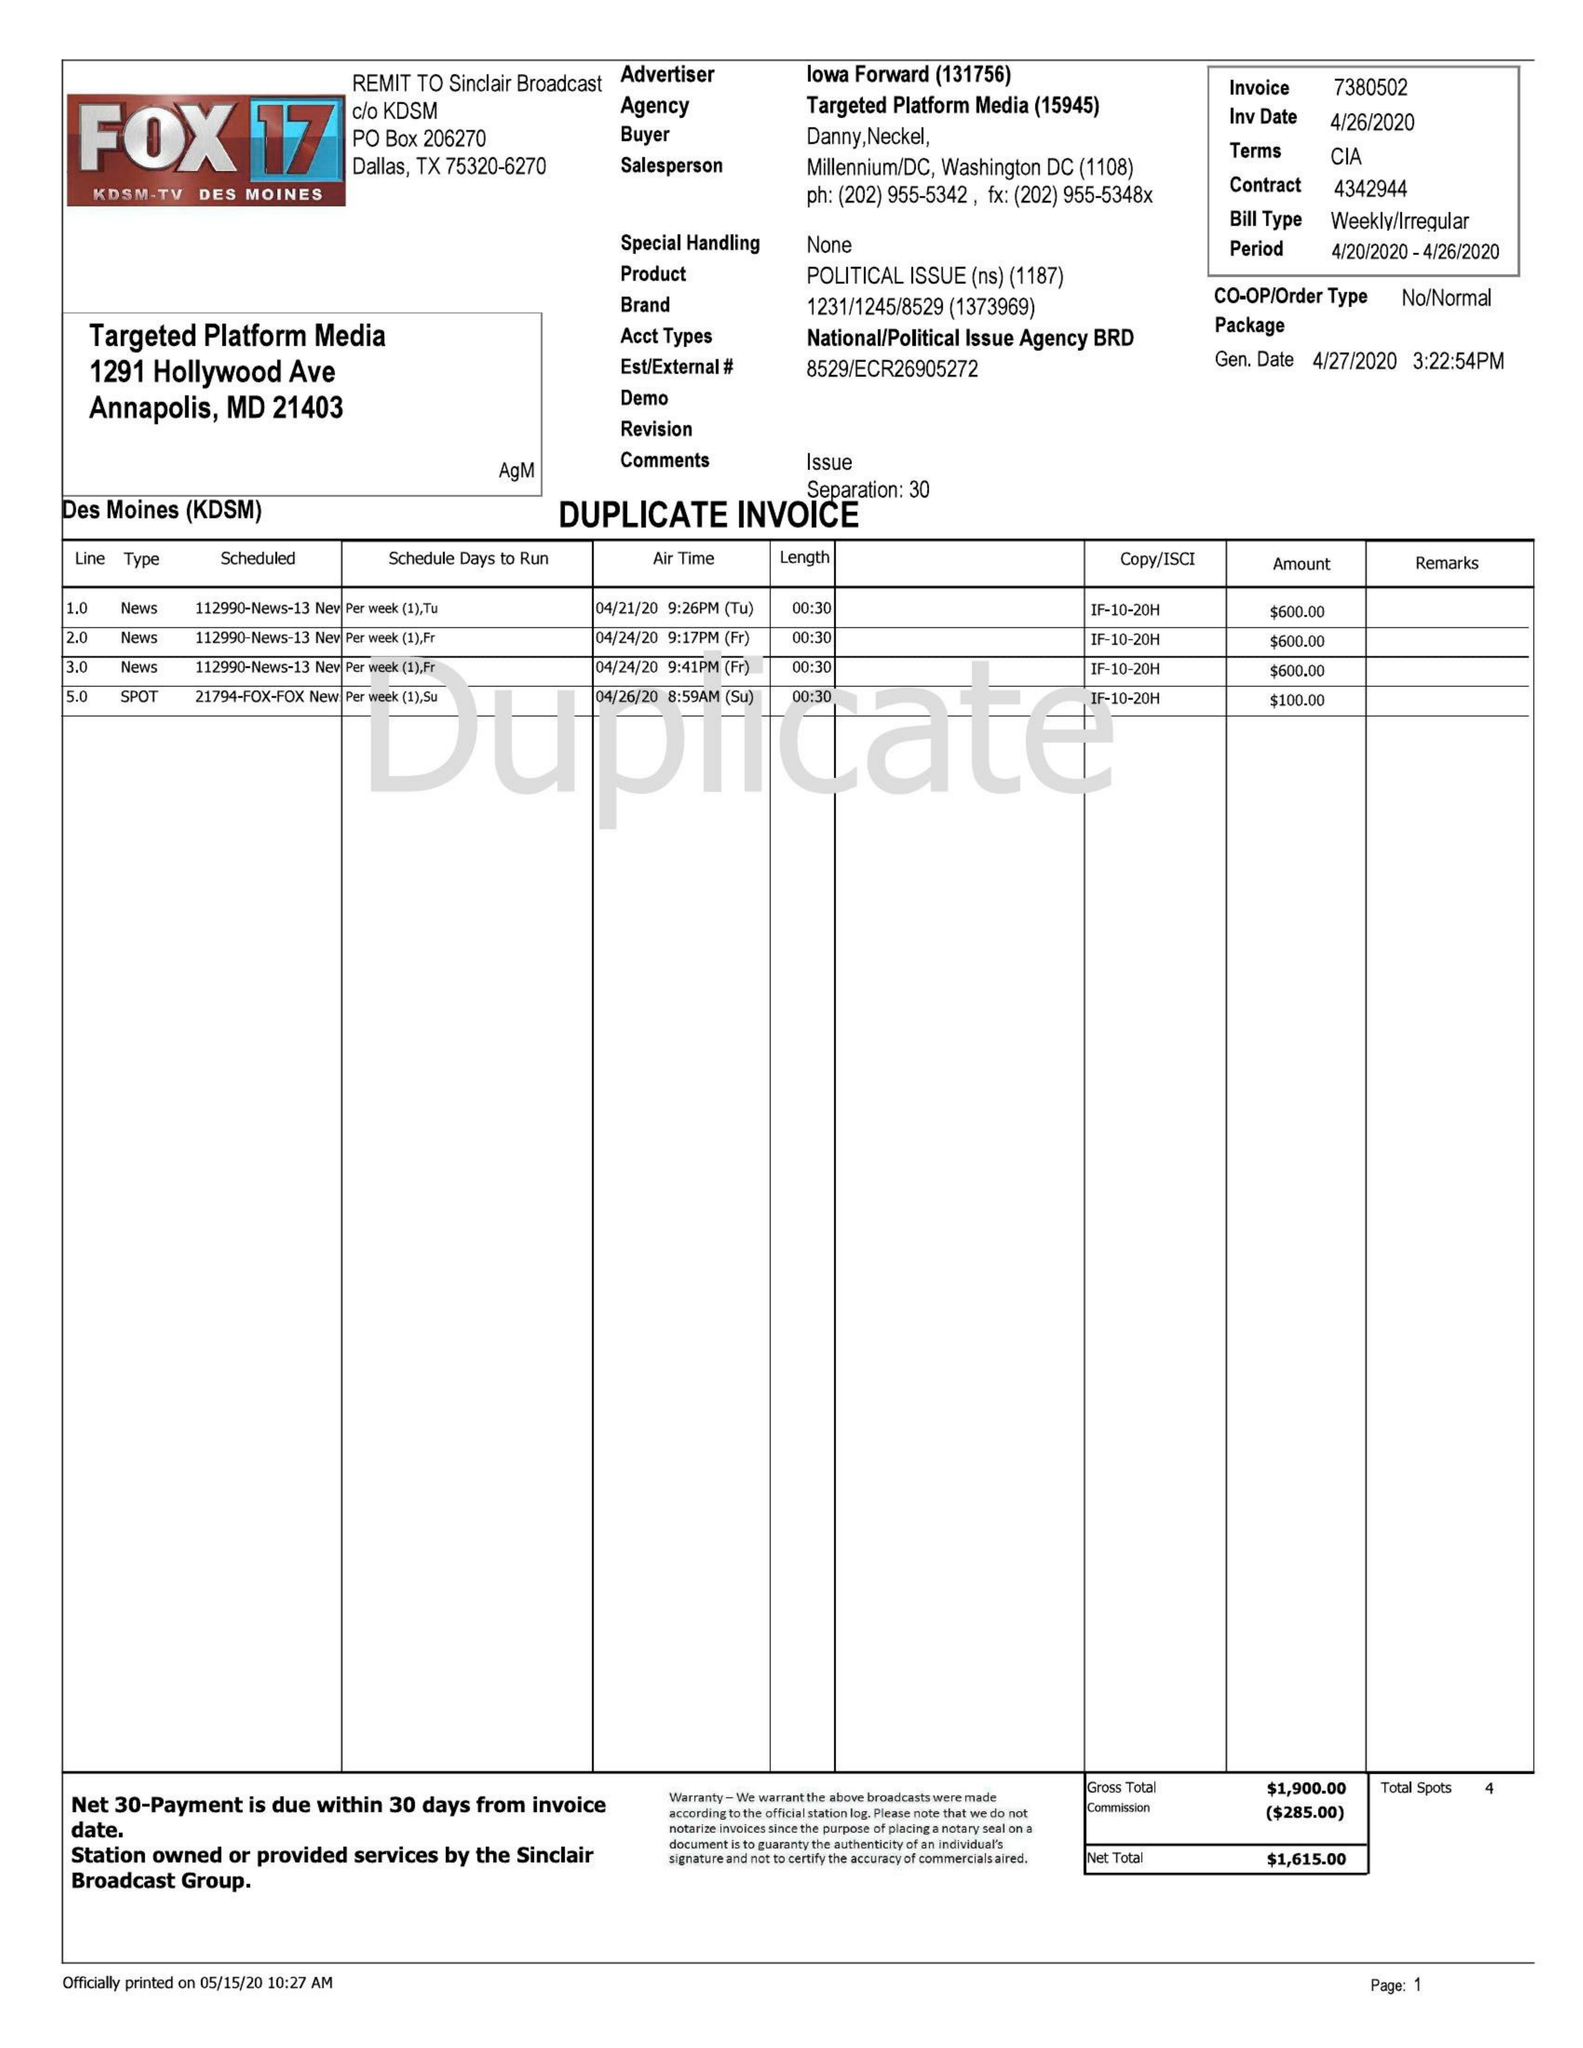What is the value for the flight_to?
Answer the question using a single word or phrase. 04/26/20 